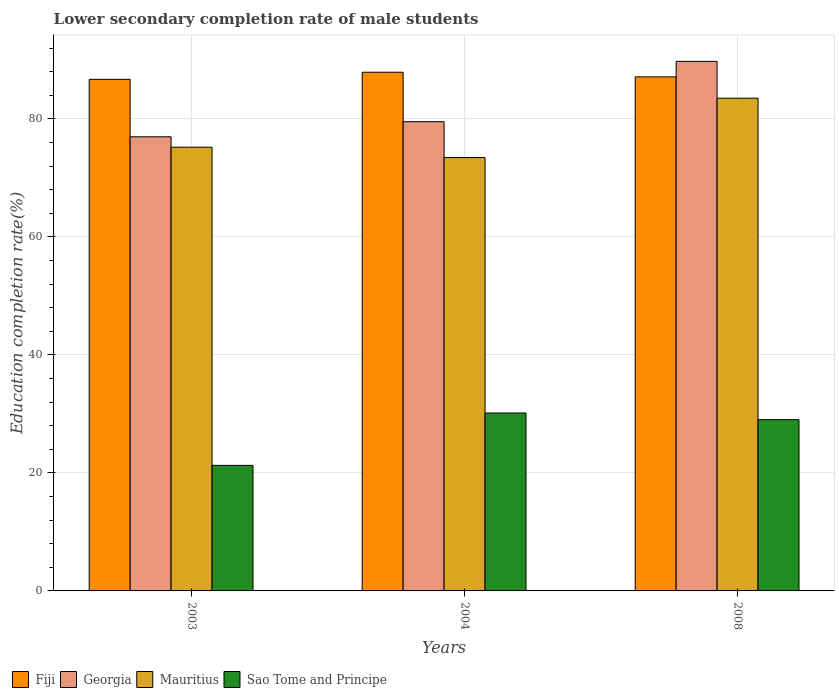How many different coloured bars are there?
Your answer should be very brief. 4. How many groups of bars are there?
Your answer should be very brief. 3. Are the number of bars per tick equal to the number of legend labels?
Keep it short and to the point. Yes. How many bars are there on the 3rd tick from the left?
Offer a very short reply. 4. How many bars are there on the 2nd tick from the right?
Offer a terse response. 4. In how many cases, is the number of bars for a given year not equal to the number of legend labels?
Your response must be concise. 0. What is the lower secondary completion rate of male students in Fiji in 2003?
Offer a very short reply. 86.7. Across all years, what is the maximum lower secondary completion rate of male students in Georgia?
Offer a very short reply. 89.75. Across all years, what is the minimum lower secondary completion rate of male students in Fiji?
Your response must be concise. 86.7. What is the total lower secondary completion rate of male students in Fiji in the graph?
Offer a terse response. 261.73. What is the difference between the lower secondary completion rate of male students in Sao Tome and Principe in 2003 and that in 2008?
Your response must be concise. -7.75. What is the difference between the lower secondary completion rate of male students in Mauritius in 2003 and the lower secondary completion rate of male students in Georgia in 2004?
Your answer should be very brief. -4.31. What is the average lower secondary completion rate of male students in Georgia per year?
Offer a very short reply. 82.08. In the year 2004, what is the difference between the lower secondary completion rate of male students in Mauritius and lower secondary completion rate of male students in Sao Tome and Principe?
Offer a terse response. 43.29. What is the ratio of the lower secondary completion rate of male students in Mauritius in 2003 to that in 2004?
Offer a terse response. 1.02. Is the lower secondary completion rate of male students in Mauritius in 2003 less than that in 2008?
Your answer should be compact. Yes. What is the difference between the highest and the second highest lower secondary completion rate of male students in Sao Tome and Principe?
Give a very brief answer. 1.13. What is the difference between the highest and the lowest lower secondary completion rate of male students in Fiji?
Provide a short and direct response. 1.2. In how many years, is the lower secondary completion rate of male students in Georgia greater than the average lower secondary completion rate of male students in Georgia taken over all years?
Offer a terse response. 1. What does the 2nd bar from the left in 2003 represents?
Provide a short and direct response. Georgia. What does the 3rd bar from the right in 2008 represents?
Give a very brief answer. Georgia. How many bars are there?
Ensure brevity in your answer.  12. How many years are there in the graph?
Provide a short and direct response. 3. What is the difference between two consecutive major ticks on the Y-axis?
Give a very brief answer. 20. Are the values on the major ticks of Y-axis written in scientific E-notation?
Provide a short and direct response. No. Does the graph contain any zero values?
Offer a very short reply. No. Does the graph contain grids?
Provide a succinct answer. Yes. What is the title of the graph?
Your response must be concise. Lower secondary completion rate of male students. Does "Bolivia" appear as one of the legend labels in the graph?
Give a very brief answer. No. What is the label or title of the Y-axis?
Give a very brief answer. Education completion rate(%). What is the Education completion rate(%) of Fiji in 2003?
Make the answer very short. 86.7. What is the Education completion rate(%) of Georgia in 2003?
Your response must be concise. 76.96. What is the Education completion rate(%) in Mauritius in 2003?
Give a very brief answer. 75.21. What is the Education completion rate(%) in Sao Tome and Principe in 2003?
Give a very brief answer. 21.28. What is the Education completion rate(%) in Fiji in 2004?
Your answer should be very brief. 87.9. What is the Education completion rate(%) in Georgia in 2004?
Offer a terse response. 79.52. What is the Education completion rate(%) of Mauritius in 2004?
Keep it short and to the point. 73.45. What is the Education completion rate(%) in Sao Tome and Principe in 2004?
Provide a short and direct response. 30.15. What is the Education completion rate(%) in Fiji in 2008?
Give a very brief answer. 87.12. What is the Education completion rate(%) in Georgia in 2008?
Give a very brief answer. 89.75. What is the Education completion rate(%) in Mauritius in 2008?
Provide a succinct answer. 83.51. What is the Education completion rate(%) in Sao Tome and Principe in 2008?
Your answer should be very brief. 29.03. Across all years, what is the maximum Education completion rate(%) in Fiji?
Ensure brevity in your answer.  87.9. Across all years, what is the maximum Education completion rate(%) in Georgia?
Offer a very short reply. 89.75. Across all years, what is the maximum Education completion rate(%) in Mauritius?
Ensure brevity in your answer.  83.51. Across all years, what is the maximum Education completion rate(%) of Sao Tome and Principe?
Your answer should be compact. 30.15. Across all years, what is the minimum Education completion rate(%) of Fiji?
Provide a short and direct response. 86.7. Across all years, what is the minimum Education completion rate(%) in Georgia?
Your response must be concise. 76.96. Across all years, what is the minimum Education completion rate(%) in Mauritius?
Offer a terse response. 73.45. Across all years, what is the minimum Education completion rate(%) of Sao Tome and Principe?
Make the answer very short. 21.28. What is the total Education completion rate(%) in Fiji in the graph?
Provide a short and direct response. 261.73. What is the total Education completion rate(%) in Georgia in the graph?
Offer a terse response. 246.23. What is the total Education completion rate(%) of Mauritius in the graph?
Ensure brevity in your answer.  232.16. What is the total Education completion rate(%) in Sao Tome and Principe in the graph?
Ensure brevity in your answer.  80.46. What is the difference between the Education completion rate(%) in Fiji in 2003 and that in 2004?
Your answer should be compact. -1.2. What is the difference between the Education completion rate(%) in Georgia in 2003 and that in 2004?
Give a very brief answer. -2.56. What is the difference between the Education completion rate(%) of Mauritius in 2003 and that in 2004?
Your answer should be compact. 1.76. What is the difference between the Education completion rate(%) of Sao Tome and Principe in 2003 and that in 2004?
Your response must be concise. -8.87. What is the difference between the Education completion rate(%) of Fiji in 2003 and that in 2008?
Your response must be concise. -0.42. What is the difference between the Education completion rate(%) of Georgia in 2003 and that in 2008?
Give a very brief answer. -12.79. What is the difference between the Education completion rate(%) of Mauritius in 2003 and that in 2008?
Provide a succinct answer. -8.3. What is the difference between the Education completion rate(%) in Sao Tome and Principe in 2003 and that in 2008?
Offer a very short reply. -7.75. What is the difference between the Education completion rate(%) in Fiji in 2004 and that in 2008?
Your response must be concise. 0.78. What is the difference between the Education completion rate(%) of Georgia in 2004 and that in 2008?
Your answer should be very brief. -10.23. What is the difference between the Education completion rate(%) of Mauritius in 2004 and that in 2008?
Your response must be concise. -10.06. What is the difference between the Education completion rate(%) of Sao Tome and Principe in 2004 and that in 2008?
Make the answer very short. 1.13. What is the difference between the Education completion rate(%) in Fiji in 2003 and the Education completion rate(%) in Georgia in 2004?
Ensure brevity in your answer.  7.18. What is the difference between the Education completion rate(%) in Fiji in 2003 and the Education completion rate(%) in Mauritius in 2004?
Give a very brief answer. 13.26. What is the difference between the Education completion rate(%) in Fiji in 2003 and the Education completion rate(%) in Sao Tome and Principe in 2004?
Offer a terse response. 56.55. What is the difference between the Education completion rate(%) in Georgia in 2003 and the Education completion rate(%) in Mauritius in 2004?
Your answer should be very brief. 3.52. What is the difference between the Education completion rate(%) of Georgia in 2003 and the Education completion rate(%) of Sao Tome and Principe in 2004?
Your answer should be very brief. 46.81. What is the difference between the Education completion rate(%) of Mauritius in 2003 and the Education completion rate(%) of Sao Tome and Principe in 2004?
Provide a short and direct response. 45.05. What is the difference between the Education completion rate(%) in Fiji in 2003 and the Education completion rate(%) in Georgia in 2008?
Your answer should be compact. -3.05. What is the difference between the Education completion rate(%) of Fiji in 2003 and the Education completion rate(%) of Mauritius in 2008?
Your answer should be compact. 3.19. What is the difference between the Education completion rate(%) in Fiji in 2003 and the Education completion rate(%) in Sao Tome and Principe in 2008?
Offer a terse response. 57.68. What is the difference between the Education completion rate(%) in Georgia in 2003 and the Education completion rate(%) in Mauritius in 2008?
Make the answer very short. -6.54. What is the difference between the Education completion rate(%) in Georgia in 2003 and the Education completion rate(%) in Sao Tome and Principe in 2008?
Keep it short and to the point. 47.94. What is the difference between the Education completion rate(%) in Mauritius in 2003 and the Education completion rate(%) in Sao Tome and Principe in 2008?
Make the answer very short. 46.18. What is the difference between the Education completion rate(%) of Fiji in 2004 and the Education completion rate(%) of Georgia in 2008?
Your answer should be very brief. -1.85. What is the difference between the Education completion rate(%) in Fiji in 2004 and the Education completion rate(%) in Mauritius in 2008?
Your answer should be very brief. 4.4. What is the difference between the Education completion rate(%) in Fiji in 2004 and the Education completion rate(%) in Sao Tome and Principe in 2008?
Keep it short and to the point. 58.88. What is the difference between the Education completion rate(%) of Georgia in 2004 and the Education completion rate(%) of Mauritius in 2008?
Ensure brevity in your answer.  -3.99. What is the difference between the Education completion rate(%) in Georgia in 2004 and the Education completion rate(%) in Sao Tome and Principe in 2008?
Keep it short and to the point. 50.49. What is the difference between the Education completion rate(%) in Mauritius in 2004 and the Education completion rate(%) in Sao Tome and Principe in 2008?
Give a very brief answer. 44.42. What is the average Education completion rate(%) in Fiji per year?
Keep it short and to the point. 87.24. What is the average Education completion rate(%) in Georgia per year?
Provide a succinct answer. 82.08. What is the average Education completion rate(%) of Mauritius per year?
Provide a short and direct response. 77.39. What is the average Education completion rate(%) in Sao Tome and Principe per year?
Your answer should be compact. 26.82. In the year 2003, what is the difference between the Education completion rate(%) of Fiji and Education completion rate(%) of Georgia?
Provide a succinct answer. 9.74. In the year 2003, what is the difference between the Education completion rate(%) in Fiji and Education completion rate(%) in Mauritius?
Provide a short and direct response. 11.5. In the year 2003, what is the difference between the Education completion rate(%) of Fiji and Education completion rate(%) of Sao Tome and Principe?
Provide a succinct answer. 65.42. In the year 2003, what is the difference between the Education completion rate(%) of Georgia and Education completion rate(%) of Mauritius?
Your response must be concise. 1.76. In the year 2003, what is the difference between the Education completion rate(%) in Georgia and Education completion rate(%) in Sao Tome and Principe?
Give a very brief answer. 55.68. In the year 2003, what is the difference between the Education completion rate(%) of Mauritius and Education completion rate(%) of Sao Tome and Principe?
Your response must be concise. 53.93. In the year 2004, what is the difference between the Education completion rate(%) in Fiji and Education completion rate(%) in Georgia?
Keep it short and to the point. 8.38. In the year 2004, what is the difference between the Education completion rate(%) of Fiji and Education completion rate(%) of Mauritius?
Provide a short and direct response. 14.46. In the year 2004, what is the difference between the Education completion rate(%) of Fiji and Education completion rate(%) of Sao Tome and Principe?
Your answer should be very brief. 57.75. In the year 2004, what is the difference between the Education completion rate(%) of Georgia and Education completion rate(%) of Mauritius?
Offer a terse response. 6.07. In the year 2004, what is the difference between the Education completion rate(%) of Georgia and Education completion rate(%) of Sao Tome and Principe?
Provide a short and direct response. 49.37. In the year 2004, what is the difference between the Education completion rate(%) of Mauritius and Education completion rate(%) of Sao Tome and Principe?
Your answer should be compact. 43.29. In the year 2008, what is the difference between the Education completion rate(%) in Fiji and Education completion rate(%) in Georgia?
Give a very brief answer. -2.63. In the year 2008, what is the difference between the Education completion rate(%) in Fiji and Education completion rate(%) in Mauritius?
Give a very brief answer. 3.62. In the year 2008, what is the difference between the Education completion rate(%) of Fiji and Education completion rate(%) of Sao Tome and Principe?
Keep it short and to the point. 58.1. In the year 2008, what is the difference between the Education completion rate(%) of Georgia and Education completion rate(%) of Mauritius?
Ensure brevity in your answer.  6.24. In the year 2008, what is the difference between the Education completion rate(%) of Georgia and Education completion rate(%) of Sao Tome and Principe?
Ensure brevity in your answer.  60.72. In the year 2008, what is the difference between the Education completion rate(%) of Mauritius and Education completion rate(%) of Sao Tome and Principe?
Ensure brevity in your answer.  54.48. What is the ratio of the Education completion rate(%) in Fiji in 2003 to that in 2004?
Offer a terse response. 0.99. What is the ratio of the Education completion rate(%) of Georgia in 2003 to that in 2004?
Provide a short and direct response. 0.97. What is the ratio of the Education completion rate(%) of Mauritius in 2003 to that in 2004?
Offer a very short reply. 1.02. What is the ratio of the Education completion rate(%) of Sao Tome and Principe in 2003 to that in 2004?
Your answer should be very brief. 0.71. What is the ratio of the Education completion rate(%) in Georgia in 2003 to that in 2008?
Keep it short and to the point. 0.86. What is the ratio of the Education completion rate(%) of Mauritius in 2003 to that in 2008?
Your response must be concise. 0.9. What is the ratio of the Education completion rate(%) of Sao Tome and Principe in 2003 to that in 2008?
Keep it short and to the point. 0.73. What is the ratio of the Education completion rate(%) in Fiji in 2004 to that in 2008?
Ensure brevity in your answer.  1.01. What is the ratio of the Education completion rate(%) of Georgia in 2004 to that in 2008?
Make the answer very short. 0.89. What is the ratio of the Education completion rate(%) in Mauritius in 2004 to that in 2008?
Keep it short and to the point. 0.88. What is the ratio of the Education completion rate(%) in Sao Tome and Principe in 2004 to that in 2008?
Provide a succinct answer. 1.04. What is the difference between the highest and the second highest Education completion rate(%) of Fiji?
Ensure brevity in your answer.  0.78. What is the difference between the highest and the second highest Education completion rate(%) in Georgia?
Offer a terse response. 10.23. What is the difference between the highest and the second highest Education completion rate(%) in Mauritius?
Provide a short and direct response. 8.3. What is the difference between the highest and the second highest Education completion rate(%) in Sao Tome and Principe?
Ensure brevity in your answer.  1.13. What is the difference between the highest and the lowest Education completion rate(%) of Fiji?
Offer a terse response. 1.2. What is the difference between the highest and the lowest Education completion rate(%) in Georgia?
Offer a terse response. 12.79. What is the difference between the highest and the lowest Education completion rate(%) in Mauritius?
Give a very brief answer. 10.06. What is the difference between the highest and the lowest Education completion rate(%) of Sao Tome and Principe?
Make the answer very short. 8.87. 